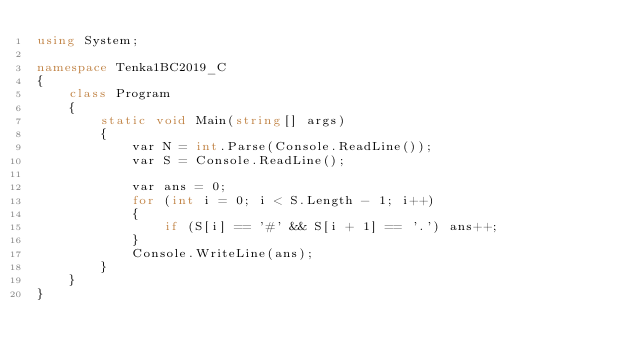Convert code to text. <code><loc_0><loc_0><loc_500><loc_500><_C#_>using System;

namespace Tenka1BC2019_C
{
    class Program
    {
        static void Main(string[] args)
        {
            var N = int.Parse(Console.ReadLine());
            var S = Console.ReadLine();

            var ans = 0;
            for (int i = 0; i < S.Length - 1; i++)
            {
                if (S[i] == '#' && S[i + 1] == '.') ans++;
            }
            Console.WriteLine(ans);
        }
    }
}

</code> 